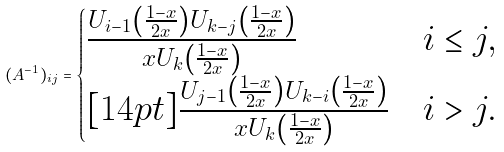<formula> <loc_0><loc_0><loc_500><loc_500>( A ^ { - 1 } ) _ { i j } = \begin{cases} \frac { U _ { i - 1 } \left ( \frac { 1 - x } { 2 x } \right ) U _ { k - j } \left ( \frac { 1 - x } { 2 x } \right ) } { x U _ { k } \left ( \frac { 1 - x } { 2 x } \right ) } & i \leq j , \\ [ 1 4 p t ] \frac { U _ { j - 1 } \left ( \frac { 1 - x } { 2 x } \right ) U _ { k - i } \left ( \frac { 1 - x } { 2 x } \right ) } { x U _ { k } \left ( \frac { 1 - x } { 2 x } \right ) } & i > j . \end{cases}</formula> 